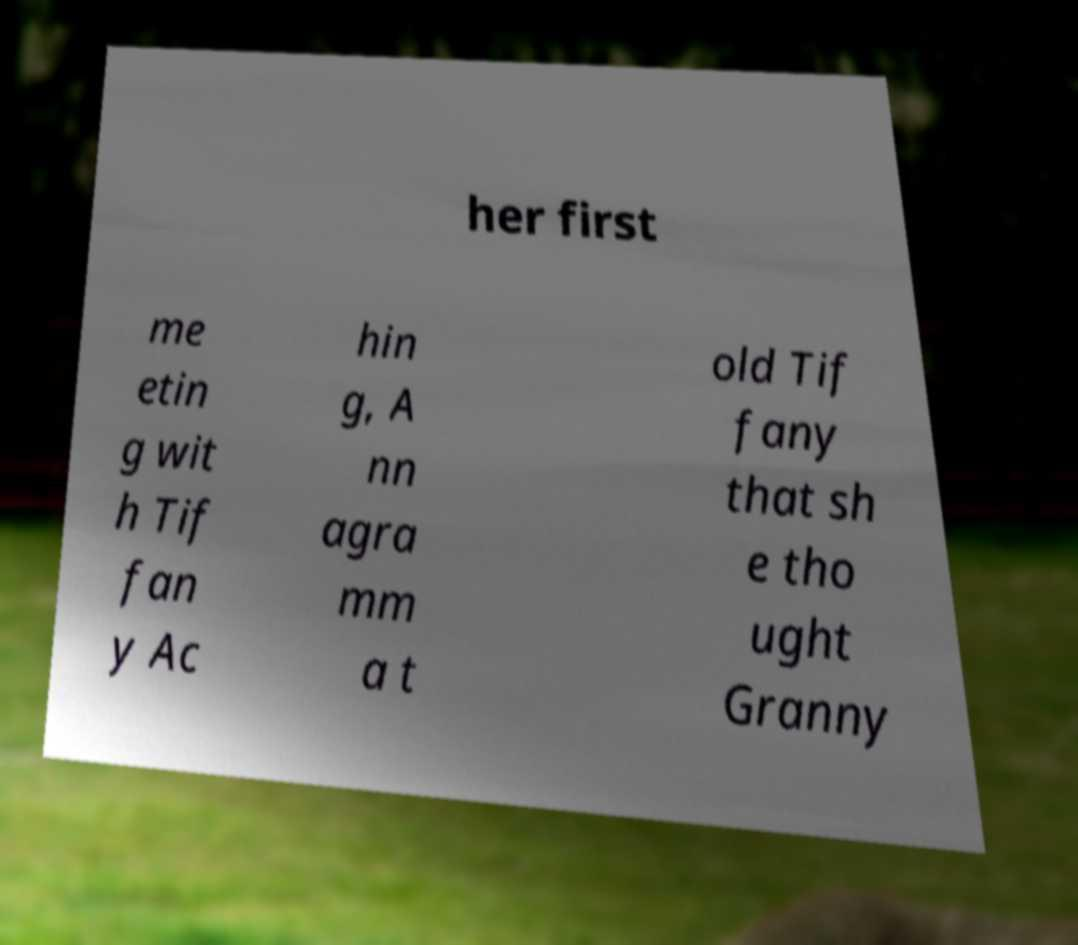For documentation purposes, I need the text within this image transcribed. Could you provide that? her first me etin g wit h Tif fan y Ac hin g, A nn agra mm a t old Tif fany that sh e tho ught Granny 